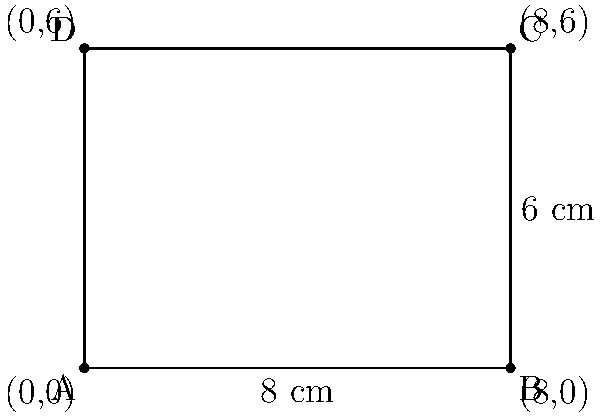You are designing a new subscription box for classic men's accessories. The box is represented by a rectangle in the coordinate plane, with corners at (0,0), (8,0), (8,6), and (0,6), where each unit represents 1 cm. Calculate the area of the box in square centimeters. To calculate the area of the rectangular subscription box, we need to follow these steps:

1. Identify the length and width of the rectangle:
   - Length: The distance between (0,0) and (8,0) is 8 cm
   - Width: The distance between (0,0) and (0,6) is 6 cm

2. Apply the formula for the area of a rectangle:
   $$ \text{Area} = \text{length} \times \text{width} $$

3. Substitute the values:
   $$ \text{Area} = 8 \text{ cm} \times 6 \text{ cm} $$

4. Perform the multiplication:
   $$ \text{Area} = 48 \text{ cm}^2 $$

Therefore, the area of the subscription box is 48 square centimeters.
Answer: 48 cm² 